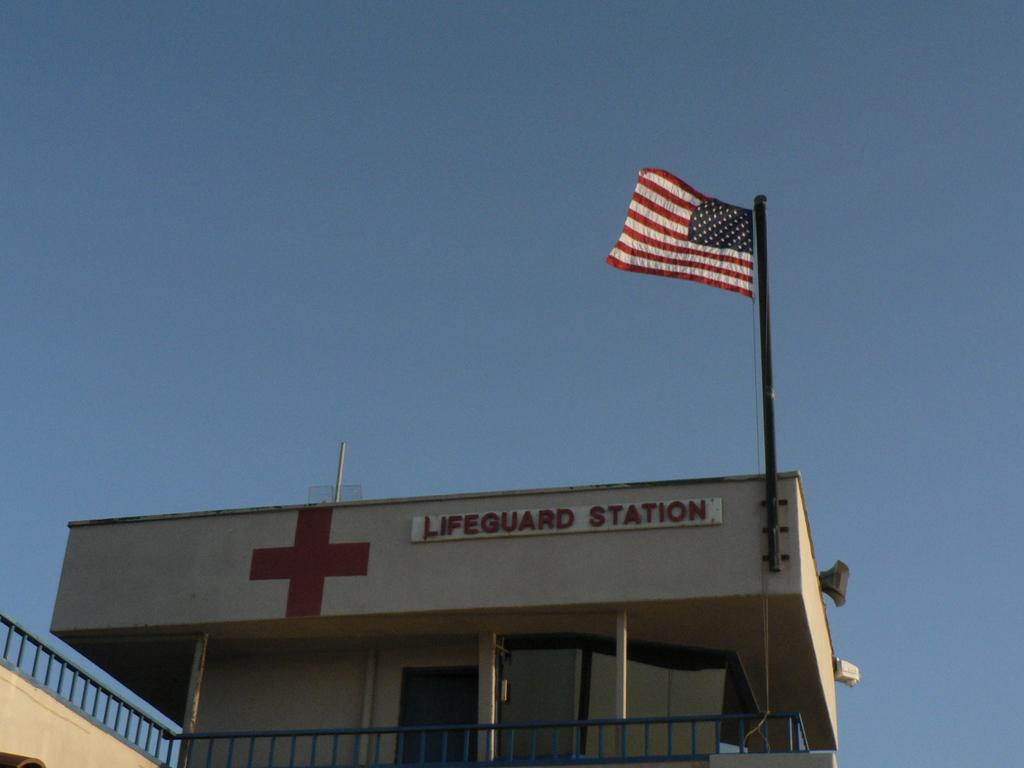What type of structure is present in the image? There is a building in the image. What can be seen flying near the building? There is a flag in the image. What type of architectural feature is visible in the image? There is railing in the image. What is visible in the background of the image? The sky is visible in the background of the image. How does the building roll down the hill in the image? The building does not roll down the hill in the image; it is stationary. 